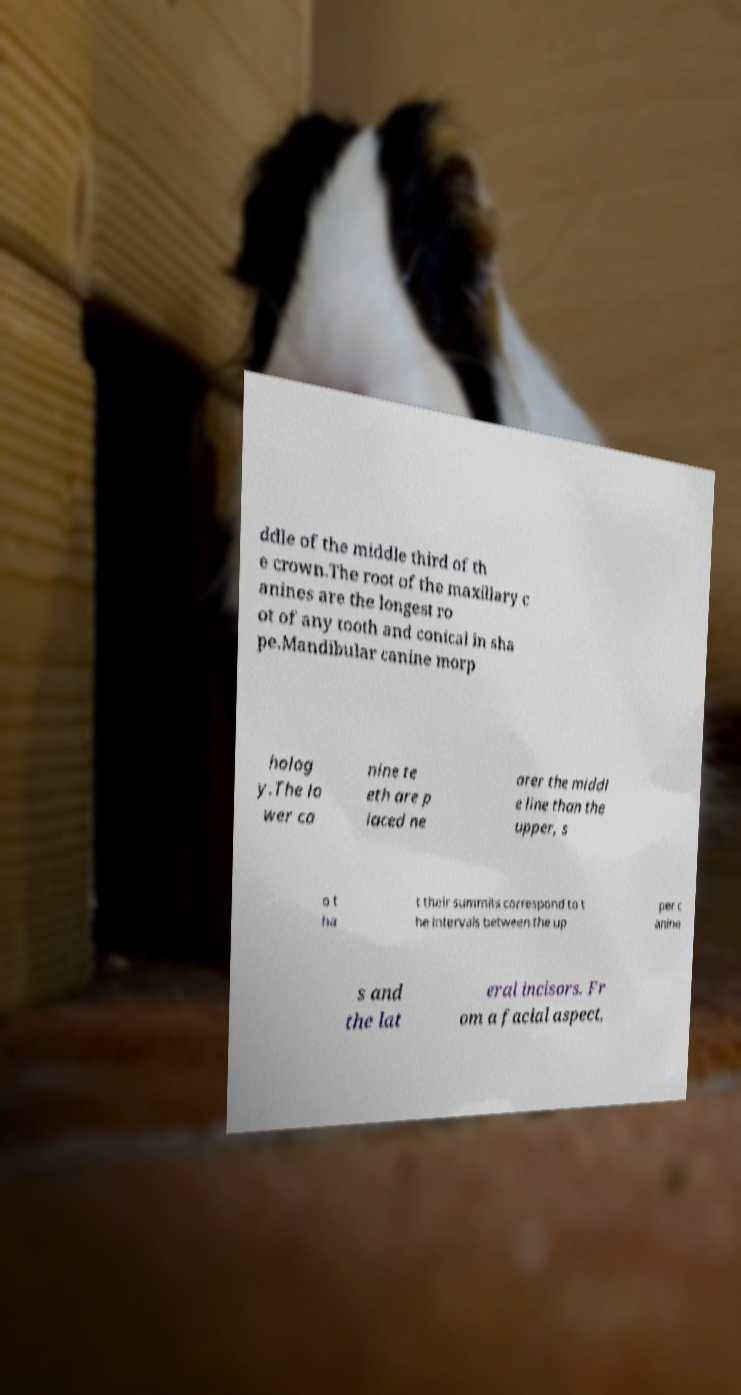I need the written content from this picture converted into text. Can you do that? ddle of the middle third of th e crown.The root of the maxillary c anines are the longest ro ot of any tooth and conical in sha pe.Mandibular canine morp holog y.The lo wer ca nine te eth are p laced ne arer the middl e line than the upper, s o t ha t their summits correspond to t he intervals between the up per c anine s and the lat eral incisors. Fr om a facial aspect, 